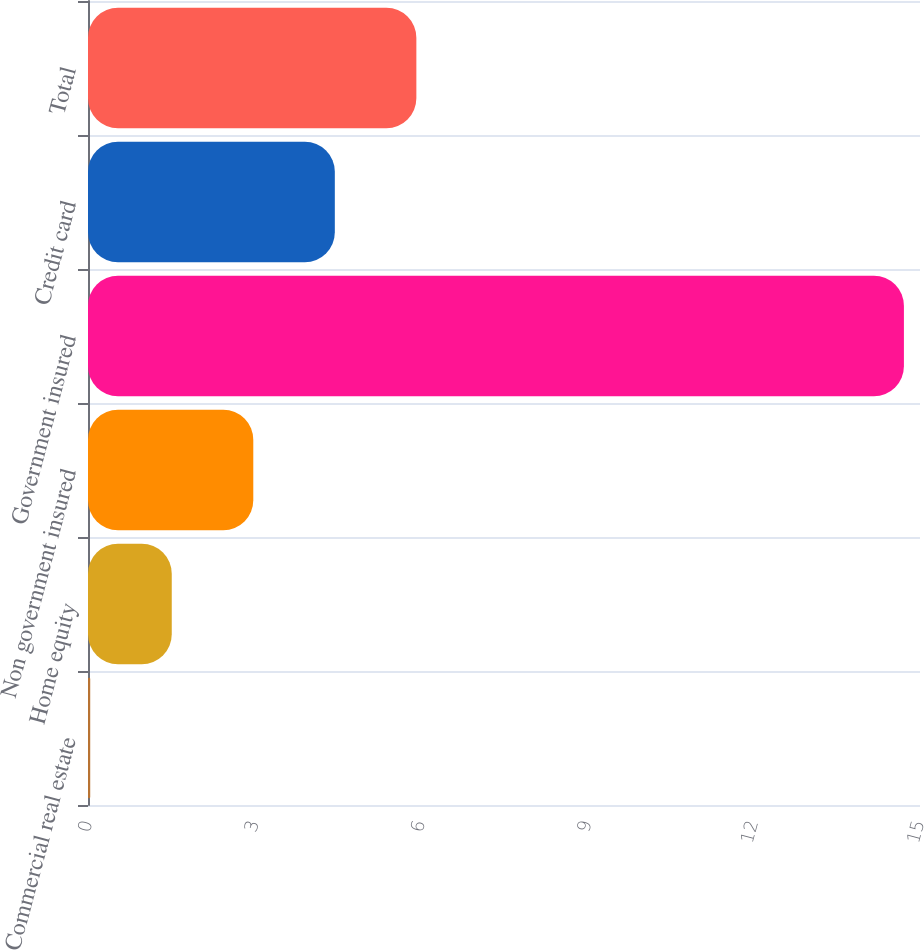Convert chart. <chart><loc_0><loc_0><loc_500><loc_500><bar_chart><fcel>Commercial real estate<fcel>Home equity<fcel>Non government insured<fcel>Government insured<fcel>Credit card<fcel>Total<nl><fcel>0.04<fcel>1.51<fcel>2.98<fcel>14.71<fcel>4.45<fcel>5.92<nl></chart> 